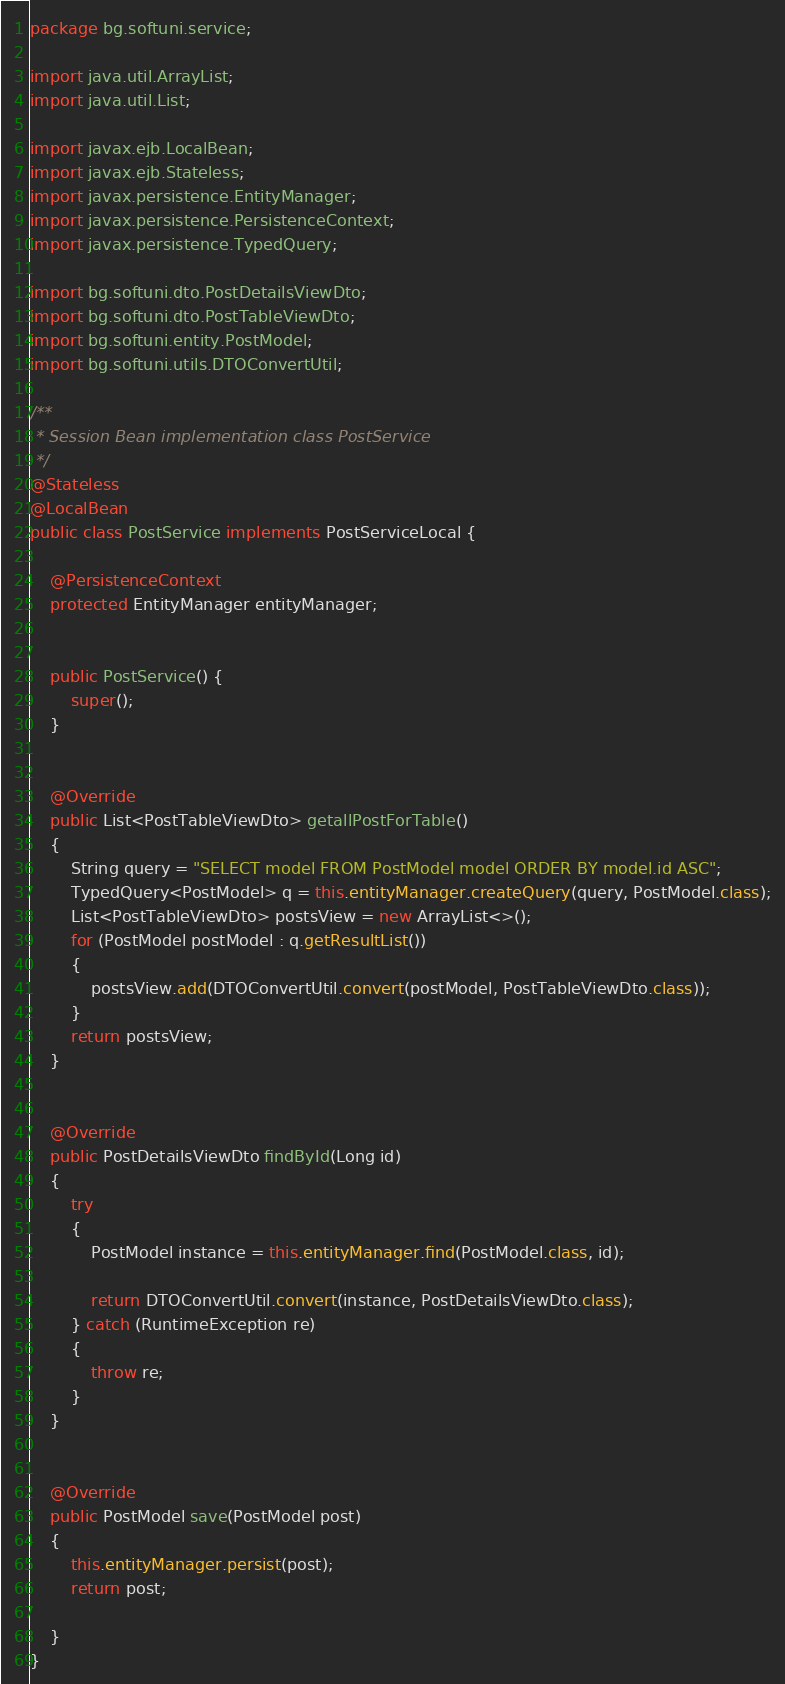<code> <loc_0><loc_0><loc_500><loc_500><_Java_>package bg.softuni.service;

import java.util.ArrayList;
import java.util.List;

import javax.ejb.LocalBean;
import javax.ejb.Stateless;
import javax.persistence.EntityManager;
import javax.persistence.PersistenceContext;
import javax.persistence.TypedQuery;

import bg.softuni.dto.PostDetailsViewDto;
import bg.softuni.dto.PostTableViewDto;
import bg.softuni.entity.PostModel;
import bg.softuni.utils.DTOConvertUtil;

/**
 * Session Bean implementation class PostService
 */
@Stateless
@LocalBean
public class PostService implements PostServiceLocal {
	
	@PersistenceContext
	protected EntityManager entityManager;

   
    public PostService() {
        super();
    }


	@Override
	public List<PostTableViewDto> getallPostForTable()
	{
		String query = "SELECT model FROM PostModel model ORDER BY model.id ASC";
		TypedQuery<PostModel> q = this.entityManager.createQuery(query, PostModel.class);
		List<PostTableViewDto> postsView = new ArrayList<>();
		for (PostModel postModel : q.getResultList())
		{
			postsView.add(DTOConvertUtil.convert(postModel, PostTableViewDto.class));
		}
		return postsView;
	}


	@Override
	public PostDetailsViewDto findById(Long id)
	{
		try
		{
			PostModel instance = this.entityManager.find(PostModel.class, id);
			
			return DTOConvertUtil.convert(instance, PostDetailsViewDto.class);
		} catch (RuntimeException re)
		{
			throw re;
		}
	}


	@Override
	public PostModel save(PostModel post)
	{
		this.entityManager.persist(post);
		return post;
		
	}
}
</code> 